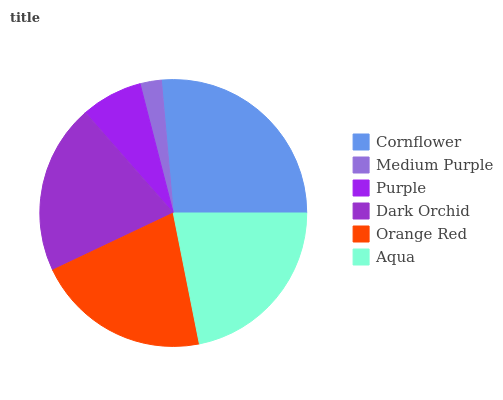Is Medium Purple the minimum?
Answer yes or no. Yes. Is Cornflower the maximum?
Answer yes or no. Yes. Is Purple the minimum?
Answer yes or no. No. Is Purple the maximum?
Answer yes or no. No. Is Purple greater than Medium Purple?
Answer yes or no. Yes. Is Medium Purple less than Purple?
Answer yes or no. Yes. Is Medium Purple greater than Purple?
Answer yes or no. No. Is Purple less than Medium Purple?
Answer yes or no. No. Is Orange Red the high median?
Answer yes or no. Yes. Is Dark Orchid the low median?
Answer yes or no. Yes. Is Cornflower the high median?
Answer yes or no. No. Is Medium Purple the low median?
Answer yes or no. No. 